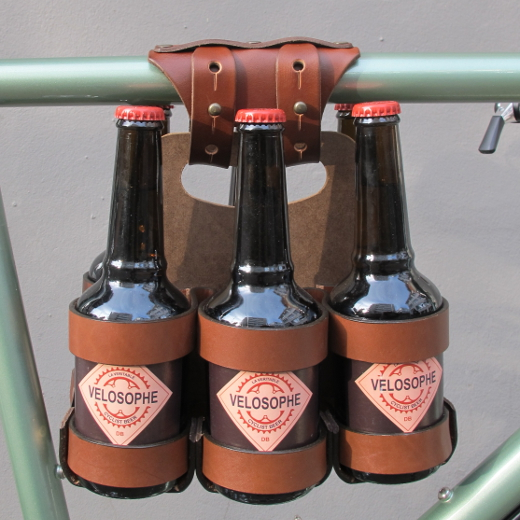What other creative uses can you think of for this bike accessory, outside of carrying beverages? Beyond carrying beverages, this bike accessory could be creatively used to hold a variety of items. For instance, it could be adapted to carry small bouquets of flowers for a charming touch when going for a leisurely ride. It could also be used to hold rolled-up picnic blankets or small outdoor accessories like a set of camping utensils, enabling you to gear up for a day of adventure with ease and style. In a practical sense, how else could someone use this accessory? Pragmatically, this accessory could be handy for carrying tools or supplies needed for bike repairs on the go. It could hold items like a mini pump, tire repair kit, and multi-tool, keeping them easily accessible while ensuring they're securely stored. This transforms the holder into a multi-functional companion for any cyclist. 